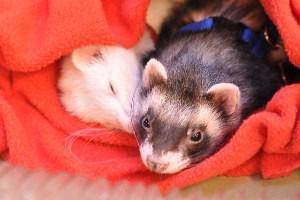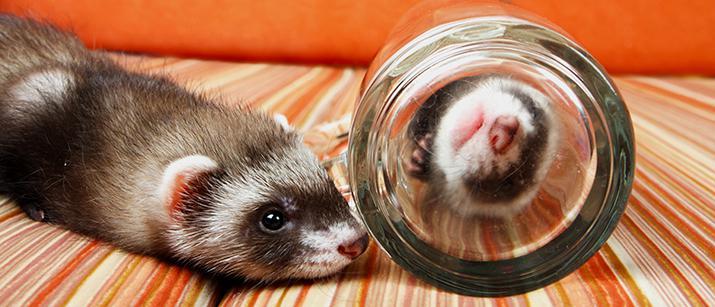The first image is the image on the left, the second image is the image on the right. Given the left and right images, does the statement "There is one ferret in the right image with its eyes closed." hold true? Answer yes or no. No. The first image is the image on the left, the second image is the image on the right. For the images displayed, is the sentence "There is at least one white ferreton a blanket with another ferret." factually correct? Answer yes or no. Yes. 